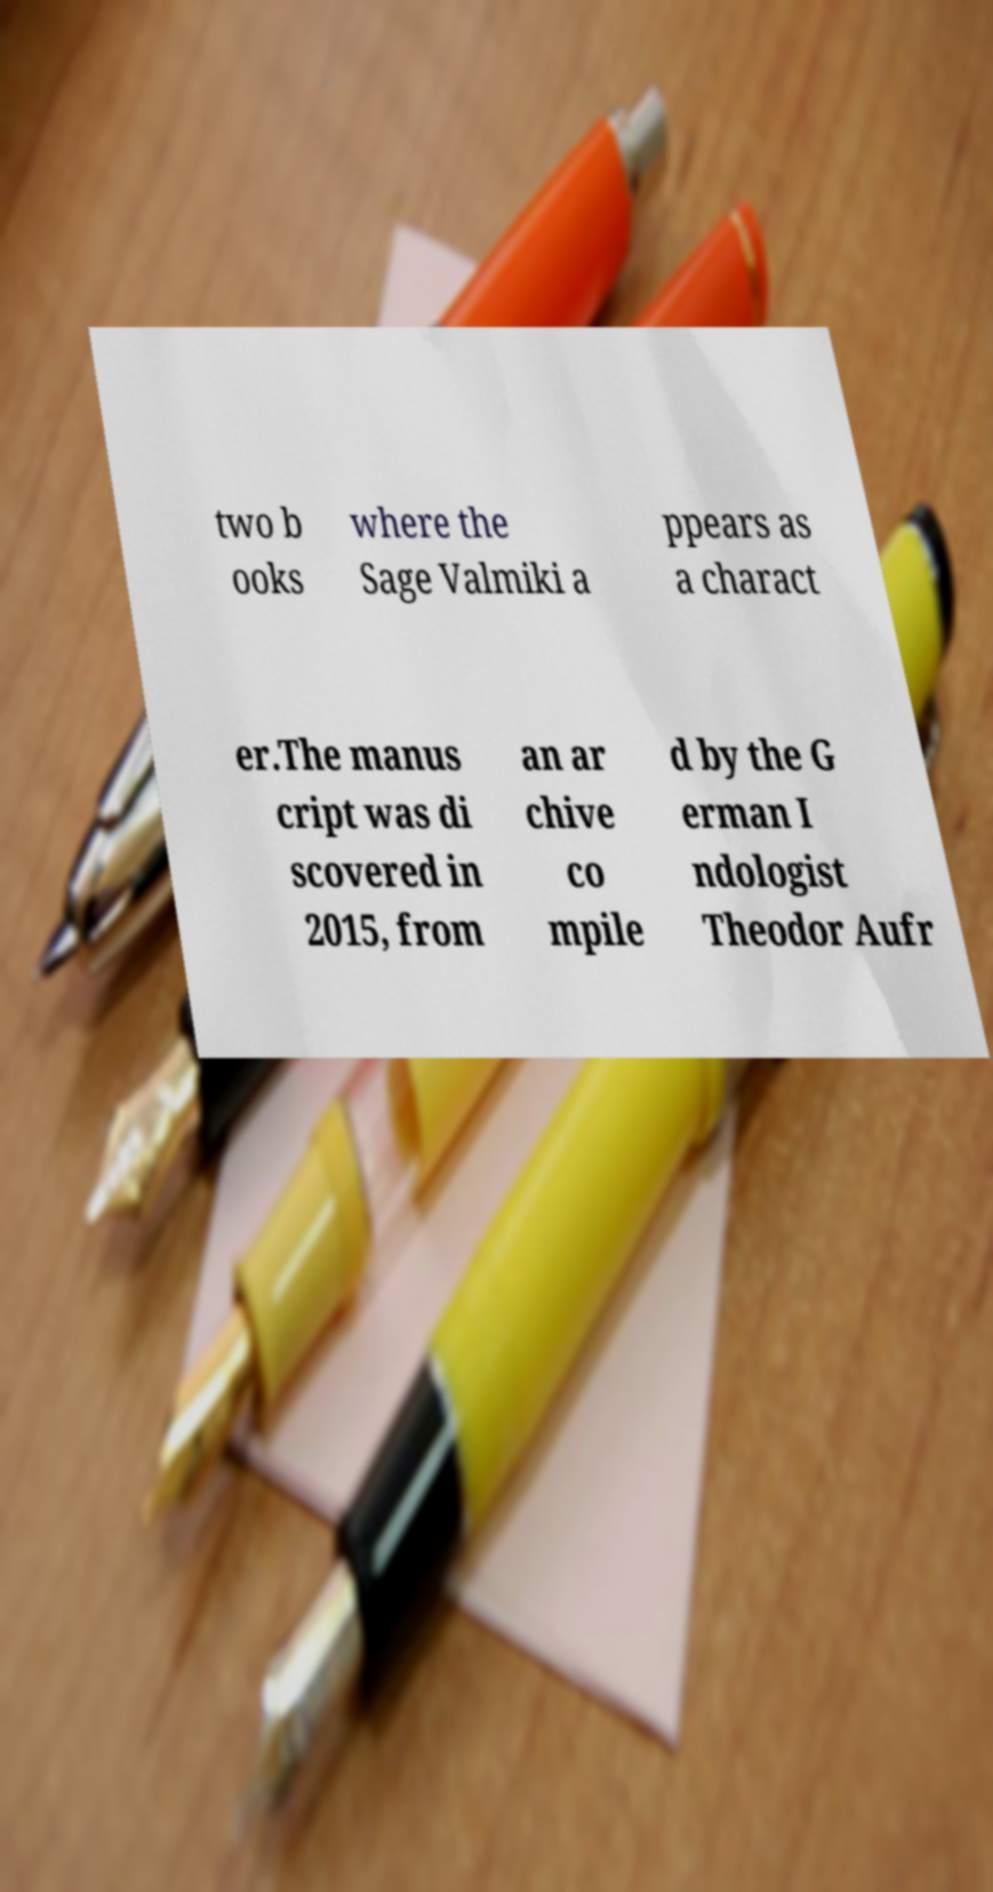What messages or text are displayed in this image? I need them in a readable, typed format. two b ooks where the Sage Valmiki a ppears as a charact er.The manus cript was di scovered in 2015, from an ar chive co mpile d by the G erman I ndologist Theodor Aufr 